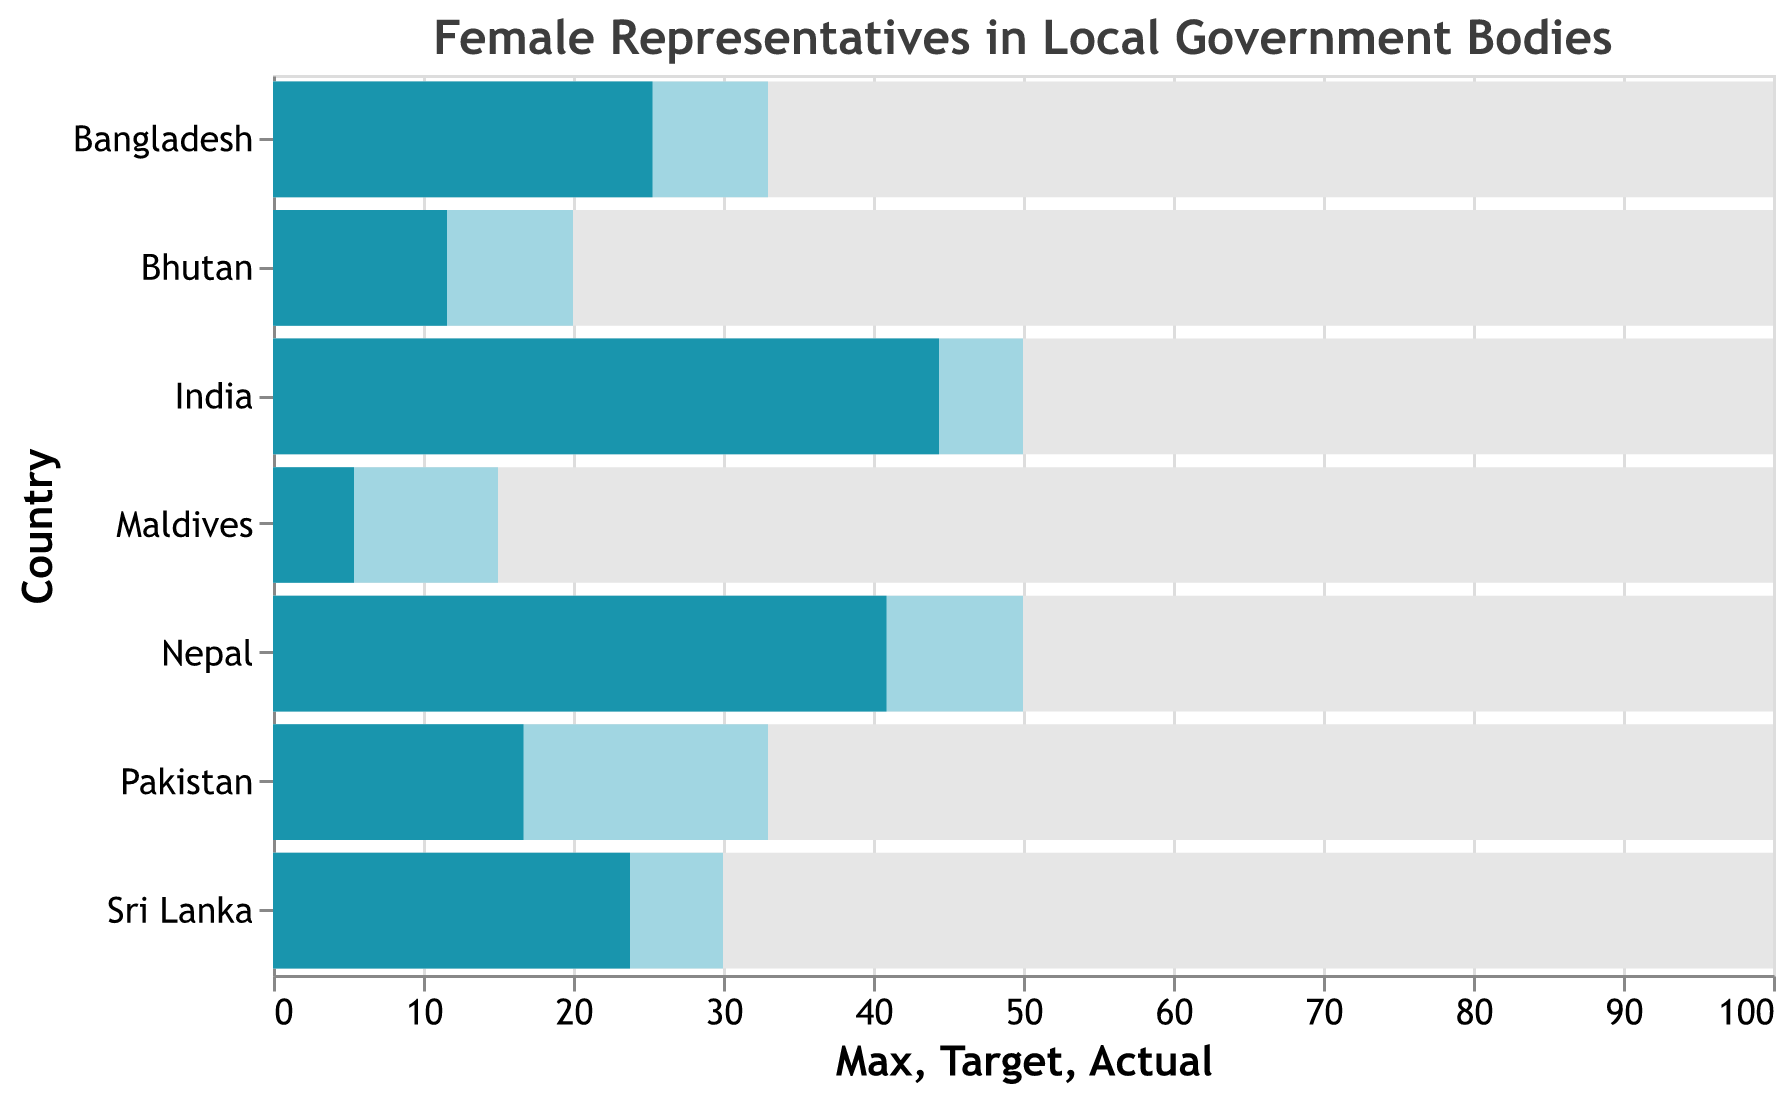What is the title of the figure? The title of the figure is displayed at the top. It reads "Female Representatives in Local Government Bodies".
Answer: Female Representatives in Local Government Bodies Which country has the highest percentage of elected female representatives in local government bodies? India's bar is the longest among all the countries, indicating it has the highest percentage of elected female representatives.
Answer: India What is the actual percentage of elected female representatives in local government bodies for Nepal? The actual value from the 'Actual' bar for Nepal is displayed at 40.9.
Answer: 40.9 How does Sri Lanka's target percentage of female representatives compare to its actual percentage? For Sri Lanka, the 'Target' bar is at 30, and the 'Actual' bar is at 23.8, which shows that the actual percentage is lower than the target percentage.
Answer: Lower Which country has the lowest target percentage for elected female representatives? By comparing the 'Target' values for each country, Maldives has the lowest target percentage at 15.
Answer: Maldives What is the difference between the actual and target percentages of female representatives in Bangladesh? The actual percentage for Bangladesh is 25.3, and the target percentage is 33. The difference is found by subtracting the actual from the target: 33 - 25.3 = 7.7.
Answer: 7.7 Which country is closest to meeting its target percentage of elected female representatives? By comparing the difference between 'Actual' and 'Target' values for all countries, India (44.4 actual vs. 50 target) and Nepal (40.9 actual vs. 50 target) show that both countries are not exceeding the 6 percentage points difference, but India is closer (5.6) compared to Nepal (9.1).
Answer: India What are the actual percentages of elected female representatives in both Bhutan and Maldives combined? Sum the actual values of both countries: Bhutan (11.6) + Maldives (5.4) = 11.6 + 5.4 = 17.0.
Answer: 17.0 Which country has a greater gap between its actual and target percentages, Pakistan or Bhutan? By comparing the difference: Pakistan (target 33 - actual 16.7 = 16.3), Bhutan (target 20 - actual 11.6 = 8.4). Pakistan has a greater gap.
Answer: Pakistan Which two countries have the most similar actual percentages of female representatives? Comparing the 'Actual' values visually, Bangladesh (25.3) and Sri Lanka (23.8) are the closest to each other.
Answer: Bangladesh and Sri Lanka 